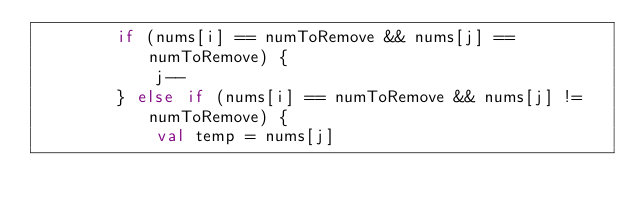Convert code to text. <code><loc_0><loc_0><loc_500><loc_500><_Kotlin_>        if (nums[i] == numToRemove && nums[j] == numToRemove) {
            j--
        } else if (nums[i] == numToRemove && nums[j] != numToRemove) {
            val temp = nums[j]</code> 